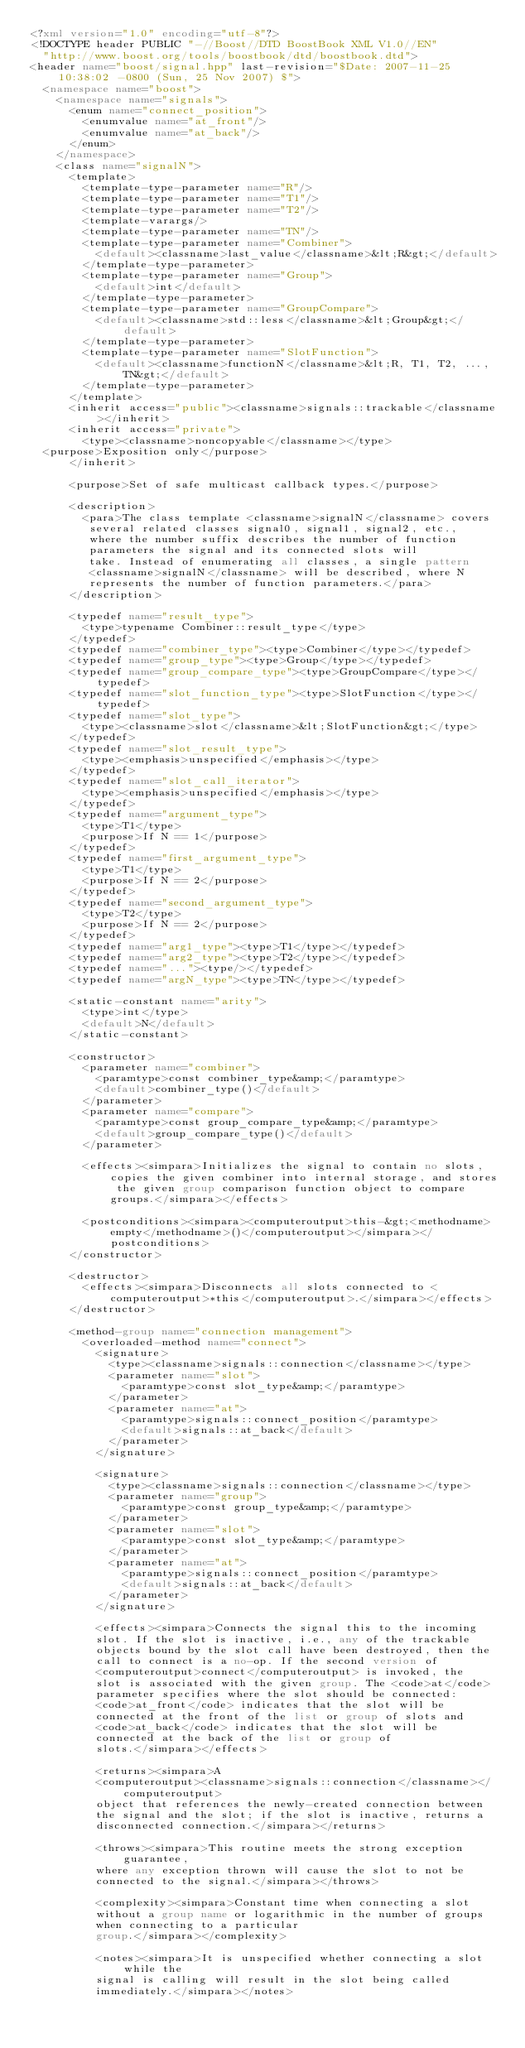Convert code to text. <code><loc_0><loc_0><loc_500><loc_500><_XML_><?xml version="1.0" encoding="utf-8"?>
<!DOCTYPE header PUBLIC "-//Boost//DTD BoostBook XML V1.0//EN"
  "http://www.boost.org/tools/boostbook/dtd/boostbook.dtd">
<header name="boost/signal.hpp" last-revision="$Date: 2007-11-25 10:38:02 -0800 (Sun, 25 Nov 2007) $">
  <namespace name="boost">
    <namespace name="signals">
      <enum name="connect_position">
        <enumvalue name="at_front"/>
        <enumvalue name="at_back"/>
      </enum>
    </namespace>
    <class name="signalN">
      <template>
        <template-type-parameter name="R"/>
        <template-type-parameter name="T1"/>
        <template-type-parameter name="T2"/>
        <template-varargs/>
        <template-type-parameter name="TN"/>
        <template-type-parameter name="Combiner">
          <default><classname>last_value</classname>&lt;R&gt;</default>
        </template-type-parameter>
        <template-type-parameter name="Group">
          <default>int</default>
        </template-type-parameter>
        <template-type-parameter name="GroupCompare">
          <default><classname>std::less</classname>&lt;Group&gt;</default>
        </template-type-parameter>
        <template-type-parameter name="SlotFunction">
          <default><classname>functionN</classname>&lt;R, T1, T2, ..., TN&gt;</default>
        </template-type-parameter>
      </template>
      <inherit access="public"><classname>signals::trackable</classname></inherit>
      <inherit access="private">
        <type><classname>noncopyable</classname></type>
	<purpose>Exposition only</purpose>
      </inherit>

      <purpose>Set of safe multicast callback types.</purpose>

      <description> 
        <para>The class template <classname>signalN</classname> covers
         several related classes signal0, signal1, signal2, etc.,
         where the number suffix describes the number of function
         parameters the signal and its connected slots will
         take. Instead of enumerating all classes, a single pattern
         <classname>signalN</classname> will be described, where N
         represents the number of function parameters.</para>
      </description>

      <typedef name="result_type">
        <type>typename Combiner::result_type</type>
      </typedef>
      <typedef name="combiner_type"><type>Combiner</type></typedef>
      <typedef name="group_type"><type>Group</type></typedef>
      <typedef name="group_compare_type"><type>GroupCompare</type></typedef>
      <typedef name="slot_function_type"><type>SlotFunction</type></typedef>
      <typedef name="slot_type">
        <type><classname>slot</classname>&lt;SlotFunction&gt;</type>
      </typedef>
      <typedef name="slot_result_type">
        <type><emphasis>unspecified</emphasis></type>
      </typedef>
      <typedef name="slot_call_iterator">
        <type><emphasis>unspecified</emphasis></type>
      </typedef>
      <typedef name="argument_type">
        <type>T1</type>
        <purpose>If N == 1</purpose>
      </typedef>
      <typedef name="first_argument_type">
        <type>T1</type>
        <purpose>If N == 2</purpose>
      </typedef>
      <typedef name="second_argument_type">
        <type>T2</type>
        <purpose>If N == 2</purpose>
      </typedef>
      <typedef name="arg1_type"><type>T1</type></typedef>
      <typedef name="arg2_type"><type>T2</type></typedef>
      <typedef name="..."><type/></typedef>
      <typedef name="argN_type"><type>TN</type></typedef>

      <static-constant name="arity">
        <type>int</type>
        <default>N</default>
      </static-constant>

      <constructor>
        <parameter name="combiner">
          <paramtype>const combiner_type&amp;</paramtype>
          <default>combiner_type()</default>
        </parameter>
        <parameter name="compare">
          <paramtype>const group_compare_type&amp;</paramtype>
          <default>group_compare_type()</default>
        </parameter>

        <effects><simpara>Initializes the signal to contain no slots, copies the given combiner into internal storage, and stores the given group comparison function object to compare groups.</simpara></effects>

        <postconditions><simpara><computeroutput>this-&gt;<methodname>empty</methodname>()</computeroutput></simpara></postconditions>
      </constructor>

      <destructor>
        <effects><simpara>Disconnects all slots connected to <computeroutput>*this</computeroutput>.</simpara></effects>
      </destructor>

      <method-group name="connection management">
        <overloaded-method name="connect">
          <signature>
            <type><classname>signals::connection</classname></type>
            <parameter name="slot">
              <paramtype>const slot_type&amp;</paramtype>
            </parameter>
            <parameter name="at">
              <paramtype>signals::connect_position</paramtype>
              <default>signals::at_back</default>
            </parameter>
          </signature>

          <signature>
            <type><classname>signals::connection</classname></type>
            <parameter name="group">
              <paramtype>const group_type&amp;</paramtype>
            </parameter>
            <parameter name="slot">
              <paramtype>const slot_type&amp;</paramtype>
            </parameter>
            <parameter name="at">
              <paramtype>signals::connect_position</paramtype>
              <default>signals::at_back</default>
            </parameter>
          </signature>

          <effects><simpara>Connects the signal this to the incoming
          slot. If the slot is inactive, i.e., any of the trackable
          objects bound by the slot call have been destroyed, then the
          call to connect is a no-op. If the second version of
          <computeroutput>connect</computeroutput> is invoked, the
          slot is associated with the given group. The <code>at</code>
          parameter specifies where the slot should be connected:
          <code>at_front</code> indicates that the slot will be
          connected at the front of the list or group of slots and
          <code>at_back</code> indicates that the slot will be
          connected at the back of the list or group of
          slots.</simpara></effects>

          <returns><simpara>A
          <computeroutput><classname>signals::connection</classname></computeroutput>
          object that references the newly-created connection between
          the signal and the slot; if the slot is inactive, returns a
          disconnected connection.</simpara></returns>

          <throws><simpara>This routine meets the strong exception guarantee,
          where any exception thrown will cause the slot to not be
          connected to the signal.</simpara></throws> 

          <complexity><simpara>Constant time when connecting a slot
          without a group name or logarithmic in the number of groups
          when connecting to a particular
          group.</simpara></complexity>

          <notes><simpara>It is unspecified whether connecting a slot while the
          signal is calling will result in the slot being called
          immediately.</simpara></notes></code> 